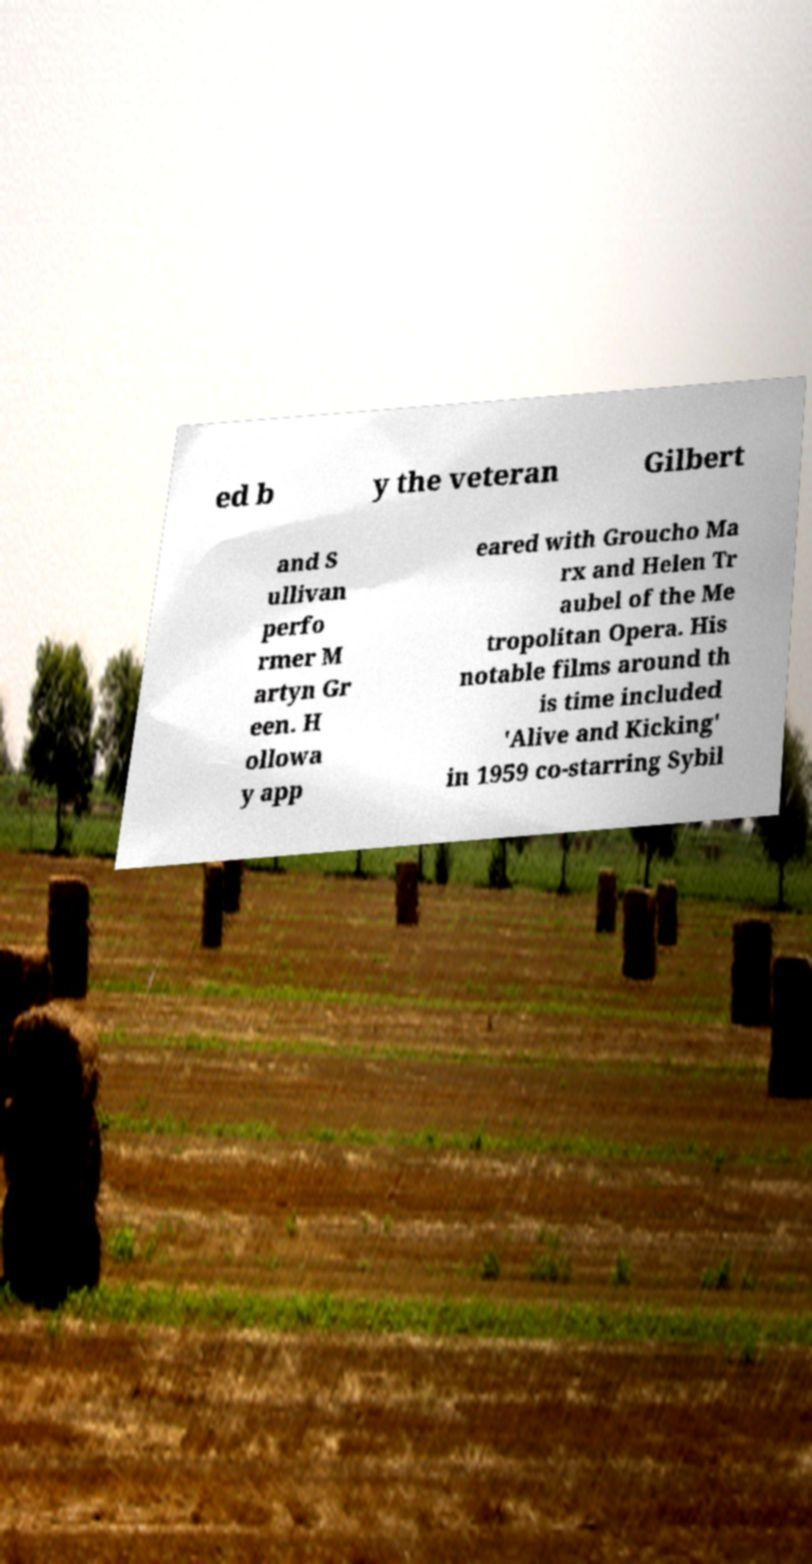I need the written content from this picture converted into text. Can you do that? ed b y the veteran Gilbert and S ullivan perfo rmer M artyn Gr een. H ollowa y app eared with Groucho Ma rx and Helen Tr aubel of the Me tropolitan Opera. His notable films around th is time included 'Alive and Kicking' in 1959 co-starring Sybil 